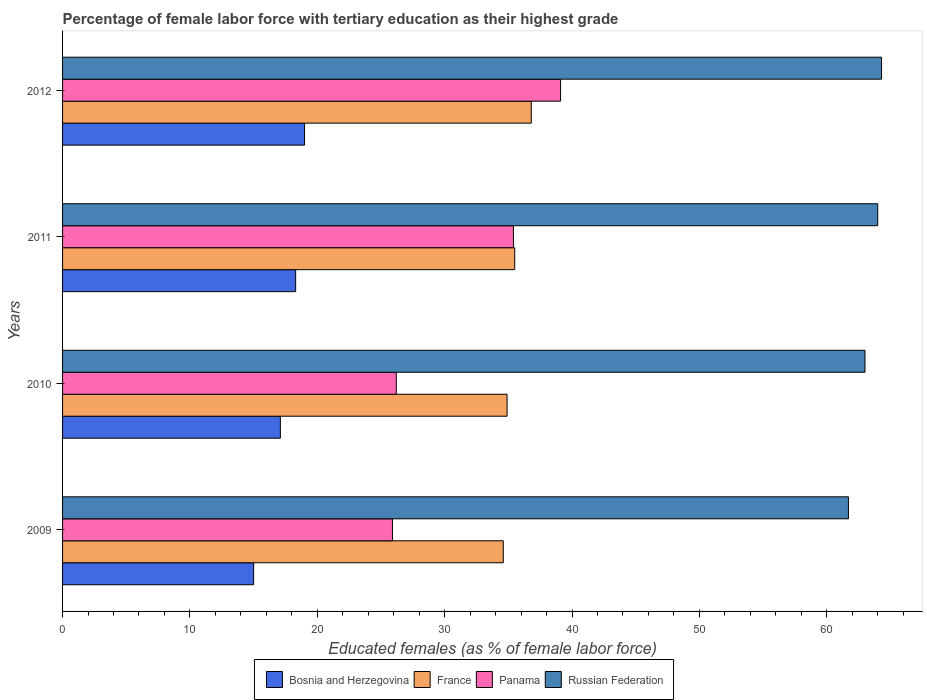How many groups of bars are there?
Your answer should be very brief. 4. Are the number of bars per tick equal to the number of legend labels?
Your response must be concise. Yes. Are the number of bars on each tick of the Y-axis equal?
Make the answer very short. Yes. How many bars are there on the 1st tick from the top?
Your response must be concise. 4. What is the label of the 3rd group of bars from the top?
Provide a short and direct response. 2010. Across all years, what is the maximum percentage of female labor force with tertiary education in France?
Your response must be concise. 36.8. Across all years, what is the minimum percentage of female labor force with tertiary education in Panama?
Your answer should be very brief. 25.9. In which year was the percentage of female labor force with tertiary education in France maximum?
Offer a terse response. 2012. In which year was the percentage of female labor force with tertiary education in Panama minimum?
Keep it short and to the point. 2009. What is the total percentage of female labor force with tertiary education in Panama in the graph?
Ensure brevity in your answer.  126.6. What is the difference between the percentage of female labor force with tertiary education in France in 2010 and that in 2012?
Provide a succinct answer. -1.9. What is the difference between the percentage of female labor force with tertiary education in Russian Federation in 2011 and the percentage of female labor force with tertiary education in France in 2012?
Give a very brief answer. 27.2. What is the average percentage of female labor force with tertiary education in Russian Federation per year?
Your answer should be very brief. 63.25. In the year 2010, what is the difference between the percentage of female labor force with tertiary education in France and percentage of female labor force with tertiary education in Bosnia and Herzegovina?
Offer a terse response. 17.8. In how many years, is the percentage of female labor force with tertiary education in Russian Federation greater than 48 %?
Ensure brevity in your answer.  4. What is the ratio of the percentage of female labor force with tertiary education in Bosnia and Herzegovina in 2011 to that in 2012?
Give a very brief answer. 0.96. Is the percentage of female labor force with tertiary education in France in 2009 less than that in 2011?
Your response must be concise. Yes. What is the difference between the highest and the second highest percentage of female labor force with tertiary education in Panama?
Ensure brevity in your answer.  3.7. What is the difference between the highest and the lowest percentage of female labor force with tertiary education in Russian Federation?
Your response must be concise. 2.6. Is it the case that in every year, the sum of the percentage of female labor force with tertiary education in France and percentage of female labor force with tertiary education in Bosnia and Herzegovina is greater than the sum of percentage of female labor force with tertiary education in Russian Federation and percentage of female labor force with tertiary education in Panama?
Provide a short and direct response. Yes. What does the 4th bar from the top in 2012 represents?
Offer a very short reply. Bosnia and Herzegovina. What does the 1st bar from the bottom in 2012 represents?
Make the answer very short. Bosnia and Herzegovina. Is it the case that in every year, the sum of the percentage of female labor force with tertiary education in Bosnia and Herzegovina and percentage of female labor force with tertiary education in France is greater than the percentage of female labor force with tertiary education in Panama?
Your response must be concise. Yes. How many bars are there?
Ensure brevity in your answer.  16. What is the difference between two consecutive major ticks on the X-axis?
Provide a succinct answer. 10. Does the graph contain grids?
Provide a succinct answer. No. Where does the legend appear in the graph?
Keep it short and to the point. Bottom center. How are the legend labels stacked?
Provide a short and direct response. Horizontal. What is the title of the graph?
Give a very brief answer. Percentage of female labor force with tertiary education as their highest grade. What is the label or title of the X-axis?
Your answer should be compact. Educated females (as % of female labor force). What is the label or title of the Y-axis?
Keep it short and to the point. Years. What is the Educated females (as % of female labor force) of Bosnia and Herzegovina in 2009?
Your answer should be very brief. 15. What is the Educated females (as % of female labor force) of France in 2009?
Offer a terse response. 34.6. What is the Educated females (as % of female labor force) in Panama in 2009?
Your response must be concise. 25.9. What is the Educated females (as % of female labor force) of Russian Federation in 2009?
Provide a succinct answer. 61.7. What is the Educated females (as % of female labor force) in Bosnia and Herzegovina in 2010?
Offer a terse response. 17.1. What is the Educated females (as % of female labor force) in France in 2010?
Provide a succinct answer. 34.9. What is the Educated females (as % of female labor force) in Panama in 2010?
Keep it short and to the point. 26.2. What is the Educated females (as % of female labor force) in Bosnia and Herzegovina in 2011?
Your answer should be very brief. 18.3. What is the Educated females (as % of female labor force) in France in 2011?
Your answer should be compact. 35.5. What is the Educated females (as % of female labor force) of Panama in 2011?
Your answer should be very brief. 35.4. What is the Educated females (as % of female labor force) in Bosnia and Herzegovina in 2012?
Provide a succinct answer. 19. What is the Educated females (as % of female labor force) in France in 2012?
Your answer should be compact. 36.8. What is the Educated females (as % of female labor force) of Panama in 2012?
Ensure brevity in your answer.  39.1. What is the Educated females (as % of female labor force) in Russian Federation in 2012?
Keep it short and to the point. 64.3. Across all years, what is the maximum Educated females (as % of female labor force) of Bosnia and Herzegovina?
Your answer should be compact. 19. Across all years, what is the maximum Educated females (as % of female labor force) in France?
Ensure brevity in your answer.  36.8. Across all years, what is the maximum Educated females (as % of female labor force) of Panama?
Provide a succinct answer. 39.1. Across all years, what is the maximum Educated females (as % of female labor force) in Russian Federation?
Make the answer very short. 64.3. Across all years, what is the minimum Educated females (as % of female labor force) in France?
Give a very brief answer. 34.6. Across all years, what is the minimum Educated females (as % of female labor force) of Panama?
Provide a succinct answer. 25.9. Across all years, what is the minimum Educated females (as % of female labor force) in Russian Federation?
Keep it short and to the point. 61.7. What is the total Educated females (as % of female labor force) of Bosnia and Herzegovina in the graph?
Ensure brevity in your answer.  69.4. What is the total Educated females (as % of female labor force) in France in the graph?
Keep it short and to the point. 141.8. What is the total Educated females (as % of female labor force) in Panama in the graph?
Keep it short and to the point. 126.6. What is the total Educated females (as % of female labor force) in Russian Federation in the graph?
Give a very brief answer. 253. What is the difference between the Educated females (as % of female labor force) of Bosnia and Herzegovina in 2009 and that in 2010?
Give a very brief answer. -2.1. What is the difference between the Educated females (as % of female labor force) of France in 2009 and that in 2010?
Make the answer very short. -0.3. What is the difference between the Educated females (as % of female labor force) in Panama in 2009 and that in 2010?
Your response must be concise. -0.3. What is the difference between the Educated females (as % of female labor force) in Russian Federation in 2009 and that in 2010?
Ensure brevity in your answer.  -1.3. What is the difference between the Educated females (as % of female labor force) in Bosnia and Herzegovina in 2009 and that in 2011?
Provide a short and direct response. -3.3. What is the difference between the Educated females (as % of female labor force) in France in 2009 and that in 2011?
Your answer should be compact. -0.9. What is the difference between the Educated females (as % of female labor force) in Russian Federation in 2009 and that in 2011?
Your answer should be compact. -2.3. What is the difference between the Educated females (as % of female labor force) in Bosnia and Herzegovina in 2009 and that in 2012?
Provide a succinct answer. -4. What is the difference between the Educated females (as % of female labor force) in Panama in 2009 and that in 2012?
Offer a terse response. -13.2. What is the difference between the Educated females (as % of female labor force) of Bosnia and Herzegovina in 2010 and that in 2011?
Offer a terse response. -1.2. What is the difference between the Educated females (as % of female labor force) of France in 2010 and that in 2011?
Ensure brevity in your answer.  -0.6. What is the difference between the Educated females (as % of female labor force) of Russian Federation in 2010 and that in 2011?
Ensure brevity in your answer.  -1. What is the difference between the Educated females (as % of female labor force) in France in 2010 and that in 2012?
Make the answer very short. -1.9. What is the difference between the Educated females (as % of female labor force) in Russian Federation in 2010 and that in 2012?
Your answer should be very brief. -1.3. What is the difference between the Educated females (as % of female labor force) of Bosnia and Herzegovina in 2011 and that in 2012?
Provide a short and direct response. -0.7. What is the difference between the Educated females (as % of female labor force) in Bosnia and Herzegovina in 2009 and the Educated females (as % of female labor force) in France in 2010?
Give a very brief answer. -19.9. What is the difference between the Educated females (as % of female labor force) of Bosnia and Herzegovina in 2009 and the Educated females (as % of female labor force) of Russian Federation in 2010?
Your answer should be compact. -48. What is the difference between the Educated females (as % of female labor force) of France in 2009 and the Educated females (as % of female labor force) of Panama in 2010?
Offer a terse response. 8.4. What is the difference between the Educated females (as % of female labor force) of France in 2009 and the Educated females (as % of female labor force) of Russian Federation in 2010?
Ensure brevity in your answer.  -28.4. What is the difference between the Educated females (as % of female labor force) in Panama in 2009 and the Educated females (as % of female labor force) in Russian Federation in 2010?
Offer a very short reply. -37.1. What is the difference between the Educated females (as % of female labor force) of Bosnia and Herzegovina in 2009 and the Educated females (as % of female labor force) of France in 2011?
Ensure brevity in your answer.  -20.5. What is the difference between the Educated females (as % of female labor force) in Bosnia and Herzegovina in 2009 and the Educated females (as % of female labor force) in Panama in 2011?
Your response must be concise. -20.4. What is the difference between the Educated females (as % of female labor force) of Bosnia and Herzegovina in 2009 and the Educated females (as % of female labor force) of Russian Federation in 2011?
Offer a terse response. -49. What is the difference between the Educated females (as % of female labor force) in France in 2009 and the Educated females (as % of female labor force) in Russian Federation in 2011?
Provide a short and direct response. -29.4. What is the difference between the Educated females (as % of female labor force) of Panama in 2009 and the Educated females (as % of female labor force) of Russian Federation in 2011?
Keep it short and to the point. -38.1. What is the difference between the Educated females (as % of female labor force) of Bosnia and Herzegovina in 2009 and the Educated females (as % of female labor force) of France in 2012?
Give a very brief answer. -21.8. What is the difference between the Educated females (as % of female labor force) of Bosnia and Herzegovina in 2009 and the Educated females (as % of female labor force) of Panama in 2012?
Make the answer very short. -24.1. What is the difference between the Educated females (as % of female labor force) of Bosnia and Herzegovina in 2009 and the Educated females (as % of female labor force) of Russian Federation in 2012?
Ensure brevity in your answer.  -49.3. What is the difference between the Educated females (as % of female labor force) of France in 2009 and the Educated females (as % of female labor force) of Russian Federation in 2012?
Give a very brief answer. -29.7. What is the difference between the Educated females (as % of female labor force) in Panama in 2009 and the Educated females (as % of female labor force) in Russian Federation in 2012?
Give a very brief answer. -38.4. What is the difference between the Educated females (as % of female labor force) of Bosnia and Herzegovina in 2010 and the Educated females (as % of female labor force) of France in 2011?
Keep it short and to the point. -18.4. What is the difference between the Educated females (as % of female labor force) in Bosnia and Herzegovina in 2010 and the Educated females (as % of female labor force) in Panama in 2011?
Provide a succinct answer. -18.3. What is the difference between the Educated females (as % of female labor force) of Bosnia and Herzegovina in 2010 and the Educated females (as % of female labor force) of Russian Federation in 2011?
Make the answer very short. -46.9. What is the difference between the Educated females (as % of female labor force) in France in 2010 and the Educated females (as % of female labor force) in Panama in 2011?
Your answer should be very brief. -0.5. What is the difference between the Educated females (as % of female labor force) of France in 2010 and the Educated females (as % of female labor force) of Russian Federation in 2011?
Ensure brevity in your answer.  -29.1. What is the difference between the Educated females (as % of female labor force) of Panama in 2010 and the Educated females (as % of female labor force) of Russian Federation in 2011?
Offer a very short reply. -37.8. What is the difference between the Educated females (as % of female labor force) in Bosnia and Herzegovina in 2010 and the Educated females (as % of female labor force) in France in 2012?
Provide a short and direct response. -19.7. What is the difference between the Educated females (as % of female labor force) of Bosnia and Herzegovina in 2010 and the Educated females (as % of female labor force) of Panama in 2012?
Your answer should be compact. -22. What is the difference between the Educated females (as % of female labor force) of Bosnia and Herzegovina in 2010 and the Educated females (as % of female labor force) of Russian Federation in 2012?
Provide a short and direct response. -47.2. What is the difference between the Educated females (as % of female labor force) in France in 2010 and the Educated females (as % of female labor force) in Russian Federation in 2012?
Provide a short and direct response. -29.4. What is the difference between the Educated females (as % of female labor force) of Panama in 2010 and the Educated females (as % of female labor force) of Russian Federation in 2012?
Your response must be concise. -38.1. What is the difference between the Educated females (as % of female labor force) in Bosnia and Herzegovina in 2011 and the Educated females (as % of female labor force) in France in 2012?
Your answer should be compact. -18.5. What is the difference between the Educated females (as % of female labor force) in Bosnia and Herzegovina in 2011 and the Educated females (as % of female labor force) in Panama in 2012?
Provide a short and direct response. -20.8. What is the difference between the Educated females (as % of female labor force) in Bosnia and Herzegovina in 2011 and the Educated females (as % of female labor force) in Russian Federation in 2012?
Offer a very short reply. -46. What is the difference between the Educated females (as % of female labor force) in France in 2011 and the Educated females (as % of female labor force) in Russian Federation in 2012?
Offer a very short reply. -28.8. What is the difference between the Educated females (as % of female labor force) in Panama in 2011 and the Educated females (as % of female labor force) in Russian Federation in 2012?
Make the answer very short. -28.9. What is the average Educated females (as % of female labor force) of Bosnia and Herzegovina per year?
Provide a succinct answer. 17.35. What is the average Educated females (as % of female labor force) of France per year?
Make the answer very short. 35.45. What is the average Educated females (as % of female labor force) of Panama per year?
Your answer should be compact. 31.65. What is the average Educated females (as % of female labor force) in Russian Federation per year?
Keep it short and to the point. 63.25. In the year 2009, what is the difference between the Educated females (as % of female labor force) in Bosnia and Herzegovina and Educated females (as % of female labor force) in France?
Make the answer very short. -19.6. In the year 2009, what is the difference between the Educated females (as % of female labor force) of Bosnia and Herzegovina and Educated females (as % of female labor force) of Panama?
Provide a short and direct response. -10.9. In the year 2009, what is the difference between the Educated females (as % of female labor force) of Bosnia and Herzegovina and Educated females (as % of female labor force) of Russian Federation?
Offer a terse response. -46.7. In the year 2009, what is the difference between the Educated females (as % of female labor force) of France and Educated females (as % of female labor force) of Russian Federation?
Make the answer very short. -27.1. In the year 2009, what is the difference between the Educated females (as % of female labor force) of Panama and Educated females (as % of female labor force) of Russian Federation?
Your response must be concise. -35.8. In the year 2010, what is the difference between the Educated females (as % of female labor force) in Bosnia and Herzegovina and Educated females (as % of female labor force) in France?
Your answer should be compact. -17.8. In the year 2010, what is the difference between the Educated females (as % of female labor force) of Bosnia and Herzegovina and Educated females (as % of female labor force) of Panama?
Provide a succinct answer. -9.1. In the year 2010, what is the difference between the Educated females (as % of female labor force) of Bosnia and Herzegovina and Educated females (as % of female labor force) of Russian Federation?
Offer a terse response. -45.9. In the year 2010, what is the difference between the Educated females (as % of female labor force) in France and Educated females (as % of female labor force) in Panama?
Ensure brevity in your answer.  8.7. In the year 2010, what is the difference between the Educated females (as % of female labor force) of France and Educated females (as % of female labor force) of Russian Federation?
Give a very brief answer. -28.1. In the year 2010, what is the difference between the Educated females (as % of female labor force) of Panama and Educated females (as % of female labor force) of Russian Federation?
Provide a short and direct response. -36.8. In the year 2011, what is the difference between the Educated females (as % of female labor force) in Bosnia and Herzegovina and Educated females (as % of female labor force) in France?
Offer a very short reply. -17.2. In the year 2011, what is the difference between the Educated females (as % of female labor force) in Bosnia and Herzegovina and Educated females (as % of female labor force) in Panama?
Your answer should be very brief. -17.1. In the year 2011, what is the difference between the Educated females (as % of female labor force) in Bosnia and Herzegovina and Educated females (as % of female labor force) in Russian Federation?
Offer a very short reply. -45.7. In the year 2011, what is the difference between the Educated females (as % of female labor force) in France and Educated females (as % of female labor force) in Panama?
Your answer should be very brief. 0.1. In the year 2011, what is the difference between the Educated females (as % of female labor force) in France and Educated females (as % of female labor force) in Russian Federation?
Your answer should be compact. -28.5. In the year 2011, what is the difference between the Educated females (as % of female labor force) of Panama and Educated females (as % of female labor force) of Russian Federation?
Provide a short and direct response. -28.6. In the year 2012, what is the difference between the Educated females (as % of female labor force) of Bosnia and Herzegovina and Educated females (as % of female labor force) of France?
Make the answer very short. -17.8. In the year 2012, what is the difference between the Educated females (as % of female labor force) in Bosnia and Herzegovina and Educated females (as % of female labor force) in Panama?
Provide a succinct answer. -20.1. In the year 2012, what is the difference between the Educated females (as % of female labor force) in Bosnia and Herzegovina and Educated females (as % of female labor force) in Russian Federation?
Make the answer very short. -45.3. In the year 2012, what is the difference between the Educated females (as % of female labor force) of France and Educated females (as % of female labor force) of Panama?
Provide a short and direct response. -2.3. In the year 2012, what is the difference between the Educated females (as % of female labor force) of France and Educated females (as % of female labor force) of Russian Federation?
Your answer should be compact. -27.5. In the year 2012, what is the difference between the Educated females (as % of female labor force) of Panama and Educated females (as % of female labor force) of Russian Federation?
Ensure brevity in your answer.  -25.2. What is the ratio of the Educated females (as % of female labor force) of Bosnia and Herzegovina in 2009 to that in 2010?
Keep it short and to the point. 0.88. What is the ratio of the Educated females (as % of female labor force) of Russian Federation in 2009 to that in 2010?
Give a very brief answer. 0.98. What is the ratio of the Educated females (as % of female labor force) in Bosnia and Herzegovina in 2009 to that in 2011?
Offer a very short reply. 0.82. What is the ratio of the Educated females (as % of female labor force) in France in 2009 to that in 2011?
Your answer should be very brief. 0.97. What is the ratio of the Educated females (as % of female labor force) in Panama in 2009 to that in 2011?
Make the answer very short. 0.73. What is the ratio of the Educated females (as % of female labor force) of Russian Federation in 2009 to that in 2011?
Your answer should be very brief. 0.96. What is the ratio of the Educated females (as % of female labor force) in Bosnia and Herzegovina in 2009 to that in 2012?
Keep it short and to the point. 0.79. What is the ratio of the Educated females (as % of female labor force) in France in 2009 to that in 2012?
Provide a short and direct response. 0.94. What is the ratio of the Educated females (as % of female labor force) of Panama in 2009 to that in 2012?
Your answer should be compact. 0.66. What is the ratio of the Educated females (as % of female labor force) in Russian Federation in 2009 to that in 2012?
Your answer should be very brief. 0.96. What is the ratio of the Educated females (as % of female labor force) in Bosnia and Herzegovina in 2010 to that in 2011?
Ensure brevity in your answer.  0.93. What is the ratio of the Educated females (as % of female labor force) in France in 2010 to that in 2011?
Your response must be concise. 0.98. What is the ratio of the Educated females (as % of female labor force) in Panama in 2010 to that in 2011?
Your answer should be compact. 0.74. What is the ratio of the Educated females (as % of female labor force) of Russian Federation in 2010 to that in 2011?
Your response must be concise. 0.98. What is the ratio of the Educated females (as % of female labor force) of France in 2010 to that in 2012?
Offer a very short reply. 0.95. What is the ratio of the Educated females (as % of female labor force) in Panama in 2010 to that in 2012?
Your response must be concise. 0.67. What is the ratio of the Educated females (as % of female labor force) in Russian Federation in 2010 to that in 2012?
Offer a very short reply. 0.98. What is the ratio of the Educated females (as % of female labor force) of Bosnia and Herzegovina in 2011 to that in 2012?
Your answer should be very brief. 0.96. What is the ratio of the Educated females (as % of female labor force) of France in 2011 to that in 2012?
Ensure brevity in your answer.  0.96. What is the ratio of the Educated females (as % of female labor force) of Panama in 2011 to that in 2012?
Your response must be concise. 0.91. What is the difference between the highest and the second highest Educated females (as % of female labor force) in Bosnia and Herzegovina?
Give a very brief answer. 0.7. What is the difference between the highest and the second highest Educated females (as % of female labor force) in France?
Make the answer very short. 1.3. What is the difference between the highest and the second highest Educated females (as % of female labor force) in Russian Federation?
Your answer should be compact. 0.3. What is the difference between the highest and the lowest Educated females (as % of female labor force) of Bosnia and Herzegovina?
Give a very brief answer. 4. What is the difference between the highest and the lowest Educated females (as % of female labor force) of France?
Offer a very short reply. 2.2. What is the difference between the highest and the lowest Educated females (as % of female labor force) of Panama?
Your answer should be compact. 13.2. What is the difference between the highest and the lowest Educated females (as % of female labor force) in Russian Federation?
Offer a terse response. 2.6. 